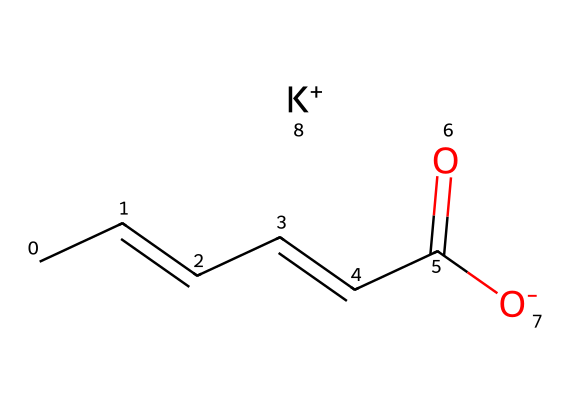What is the molecular formula of potassium sorbate? To determine the molecular formula, we need to count the atoms represented in the SMILES. We see five carbon (C) atoms, eight hydrogen (H) atoms, one oxygen (O) atom (from the carboxyl group), and one potassium (K) atom. Thus, the molecular formula is C6H7KO2.
Answer: C6H7KO2 How many carbon atoms are in the structure? By inspecting the SMILES, we can see that the 'C' symbols indicate the presence of carbon atoms. Specifically, there are six 'C' representations in the SMILES.
Answer: 6 What type of functional group is present in potassium sorbate? The chemical structure includes a carboxyl group (indicated by the -COO- part of the SMILES), which is a specific type of functional group known for its acidic properties.
Answer: carboxyl How many double bonds are present in the structure? The SMILES shows CC=CC=CC, indicating two double bonds between carbon atoms. Each "=" symbol represents one double bond. Therefore, the total number of double bonds is two.
Answer: 2 What is the charge of the potassium ion in this compound? The SMILES ends with [K+], clearly indicating that the potassium ion carries a positive charge. This is a direct interpretation of the notation used in the SMILES representation.
Answer: +1 Why is potassium sorbate used as a preservative? Potassium sorbate is known to inhibit the growth of molds and yeasts in various food products, which extends their shelf life and improves safety. This property is a result of the molecular structure and the presence of the carboxyl group that interacts with microorganisms.
Answer: inhibits mold and yeast growth What could happen if potassium sorbate were absent in energy gels? If potassium sorbate were absent, the energy gels could become susceptible to spoilage and microbial growth due to more favorable conditions for bacteria and molds, leading to shorter shelf life and potentially harmful consumption.
Answer: spoilage and harmful consumption 